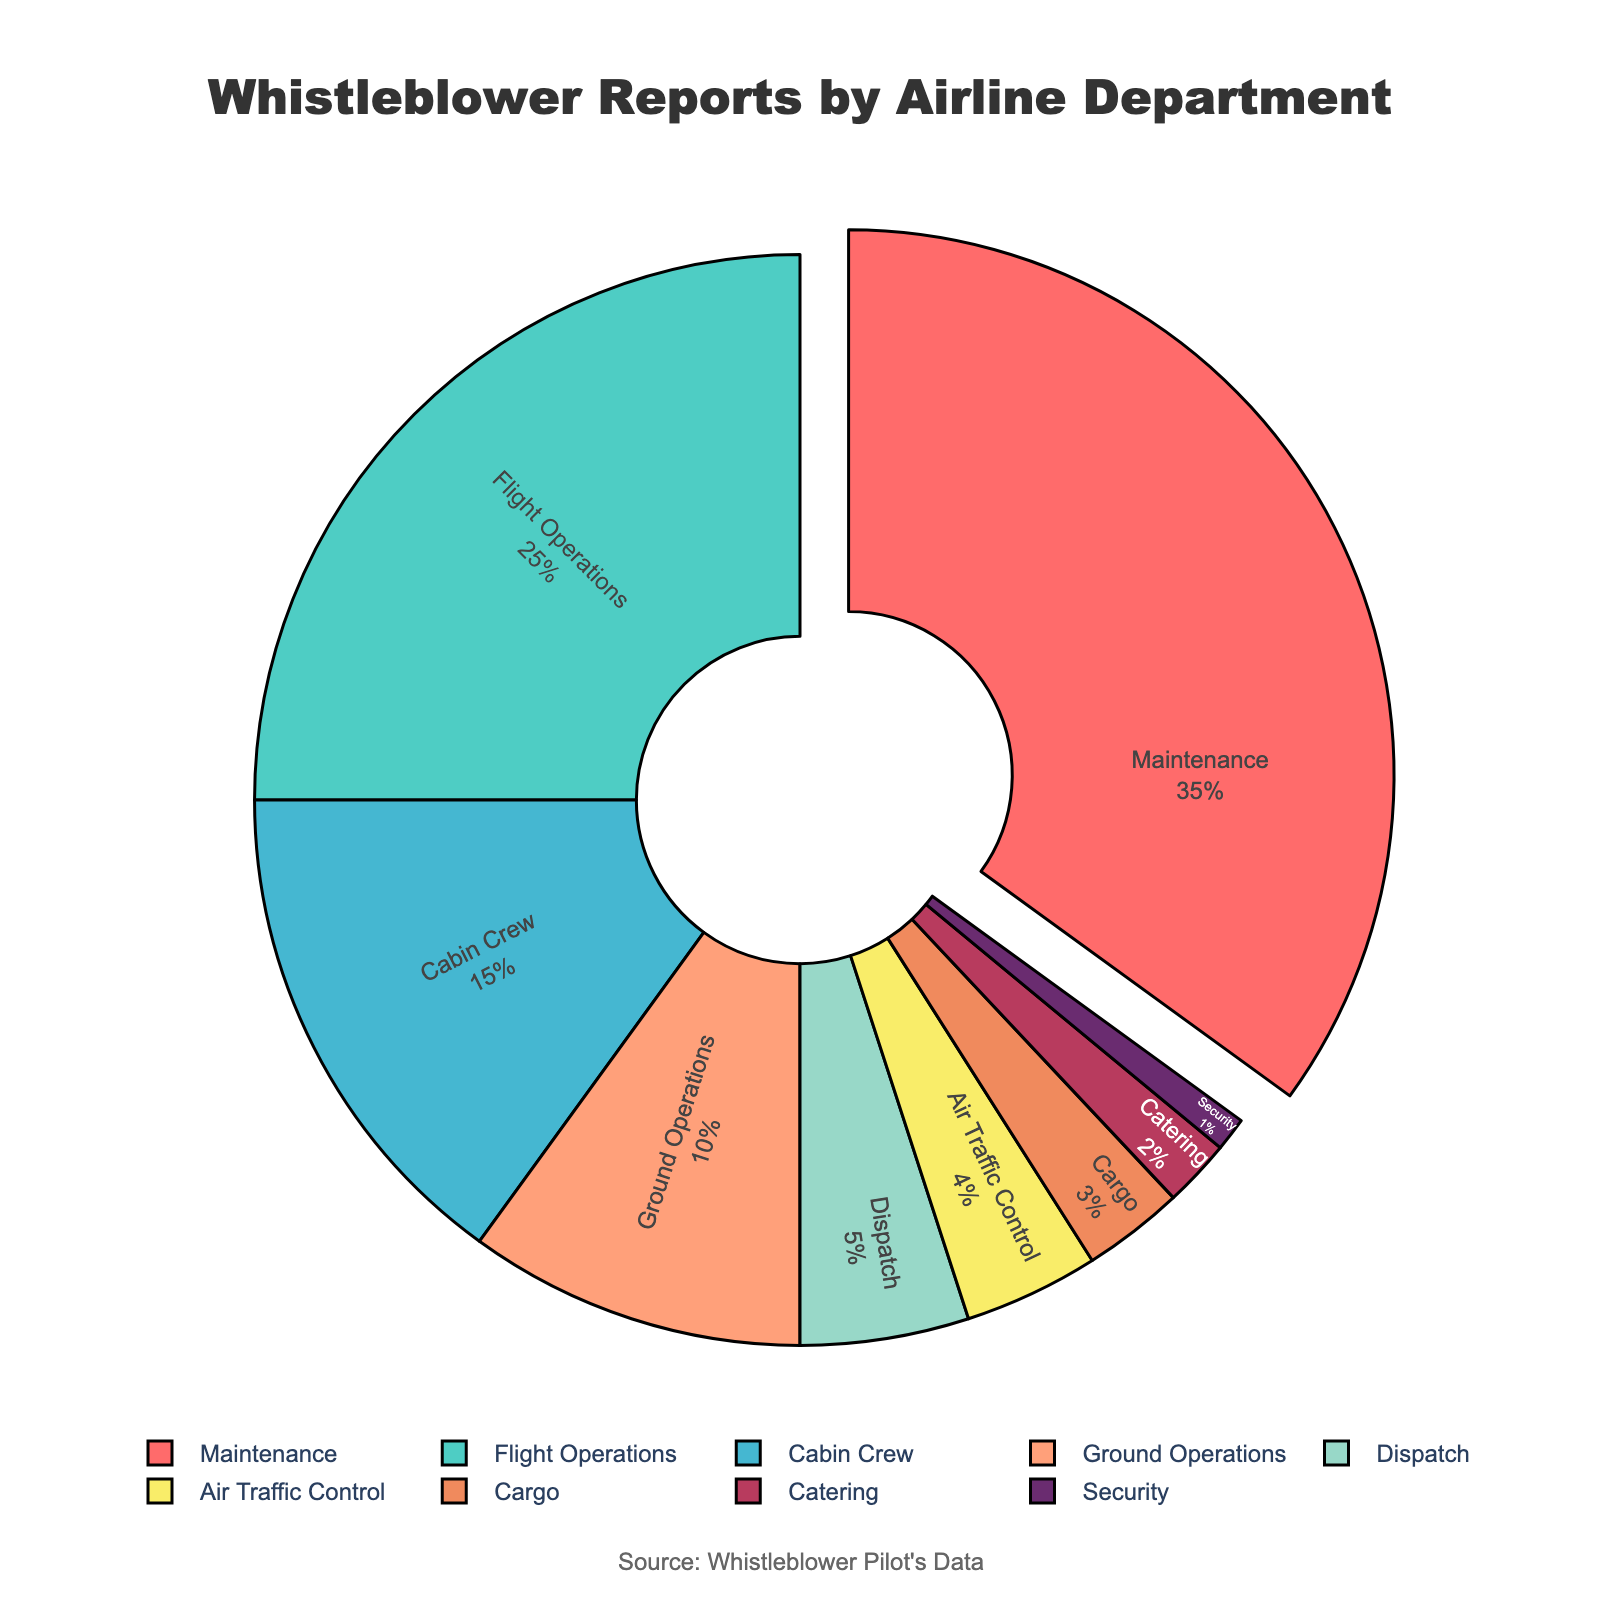What percentage of whistleblower reports are related to Maintenance? The pie chart shows that the slice labeled "Maintenance" represents 35% of the total reports.
Answer: 35% Which department has the second-highest percentage of whistleblower reports? The label "Flight Operations" corresponds to the second-largest slice, representing 25% of the total reports.
Answer: Flight Operations How much more significant is the percentage of reports for Flight Operations compared to Ground Operations? Flight Operations has 25% and Ground Operations has 10%. The difference is 25% - 10% = 15%.
Answer: 15% Do the combined reports for Ground Operations and Cabin Crew exceed those for Maintenance? Ground Operations has 10% and Cabin Crew has 15%, totaling 10% + 15% = 25%. Maintenance alone accounts for 35%, which is greater than 25%.
Answer: No What is the combined percentage of reports for Dispatch and Air Traffic Control? Dispatch has 5% and Air Traffic Control has 4%. Their combined percentage is 5% + 4% = 9%.
Answer: 9% Which department has been reported the least and what is its percentage? The smallest slice is labeled "Security," representing 1% of the total reports.
Answer: Security, 1% What percentage of reports involves either Cargo or Catering? Cargo has 3% and Catering has 2%. Their combined percentage is 3% + 2% = 5%.
Answer: 5% How does the percentage of reports for Cabin Crew compare to Cargo? Cabin Crew has 15% and Cargo has 3%. Cabin Crew has a 12% higher percentage than Cargo.
Answer: 12% higher Is the percentage of reports for Cabin Crew greater than the combined reports for Cargo, Security, and Catering? Cabin Crew has 15%. The combined reports for Cargo, Security, and Catering are 3% + 1% + 2% = 6%. Cabin Crew's 15% is greater than 6%.
Answer: Yes What percentage of reports involve departments related to in-flight activities (Cabin Crew, Flight Operations)? Cabin Crew has 15% and Flight Operations has 25%. Their combined percentage is 15% + 25% = 40%.
Answer: 40% 